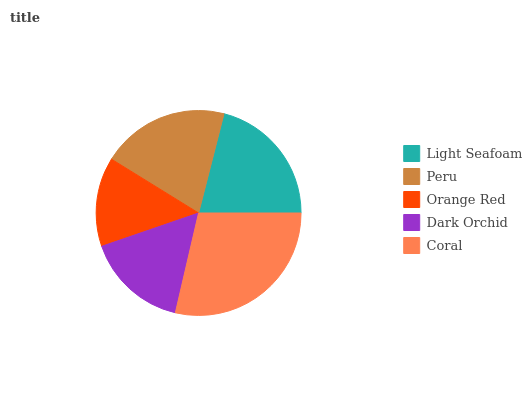Is Orange Red the minimum?
Answer yes or no. Yes. Is Coral the maximum?
Answer yes or no. Yes. Is Peru the minimum?
Answer yes or no. No. Is Peru the maximum?
Answer yes or no. No. Is Light Seafoam greater than Peru?
Answer yes or no. Yes. Is Peru less than Light Seafoam?
Answer yes or no. Yes. Is Peru greater than Light Seafoam?
Answer yes or no. No. Is Light Seafoam less than Peru?
Answer yes or no. No. Is Peru the high median?
Answer yes or no. Yes. Is Peru the low median?
Answer yes or no. Yes. Is Dark Orchid the high median?
Answer yes or no. No. Is Orange Red the low median?
Answer yes or no. No. 